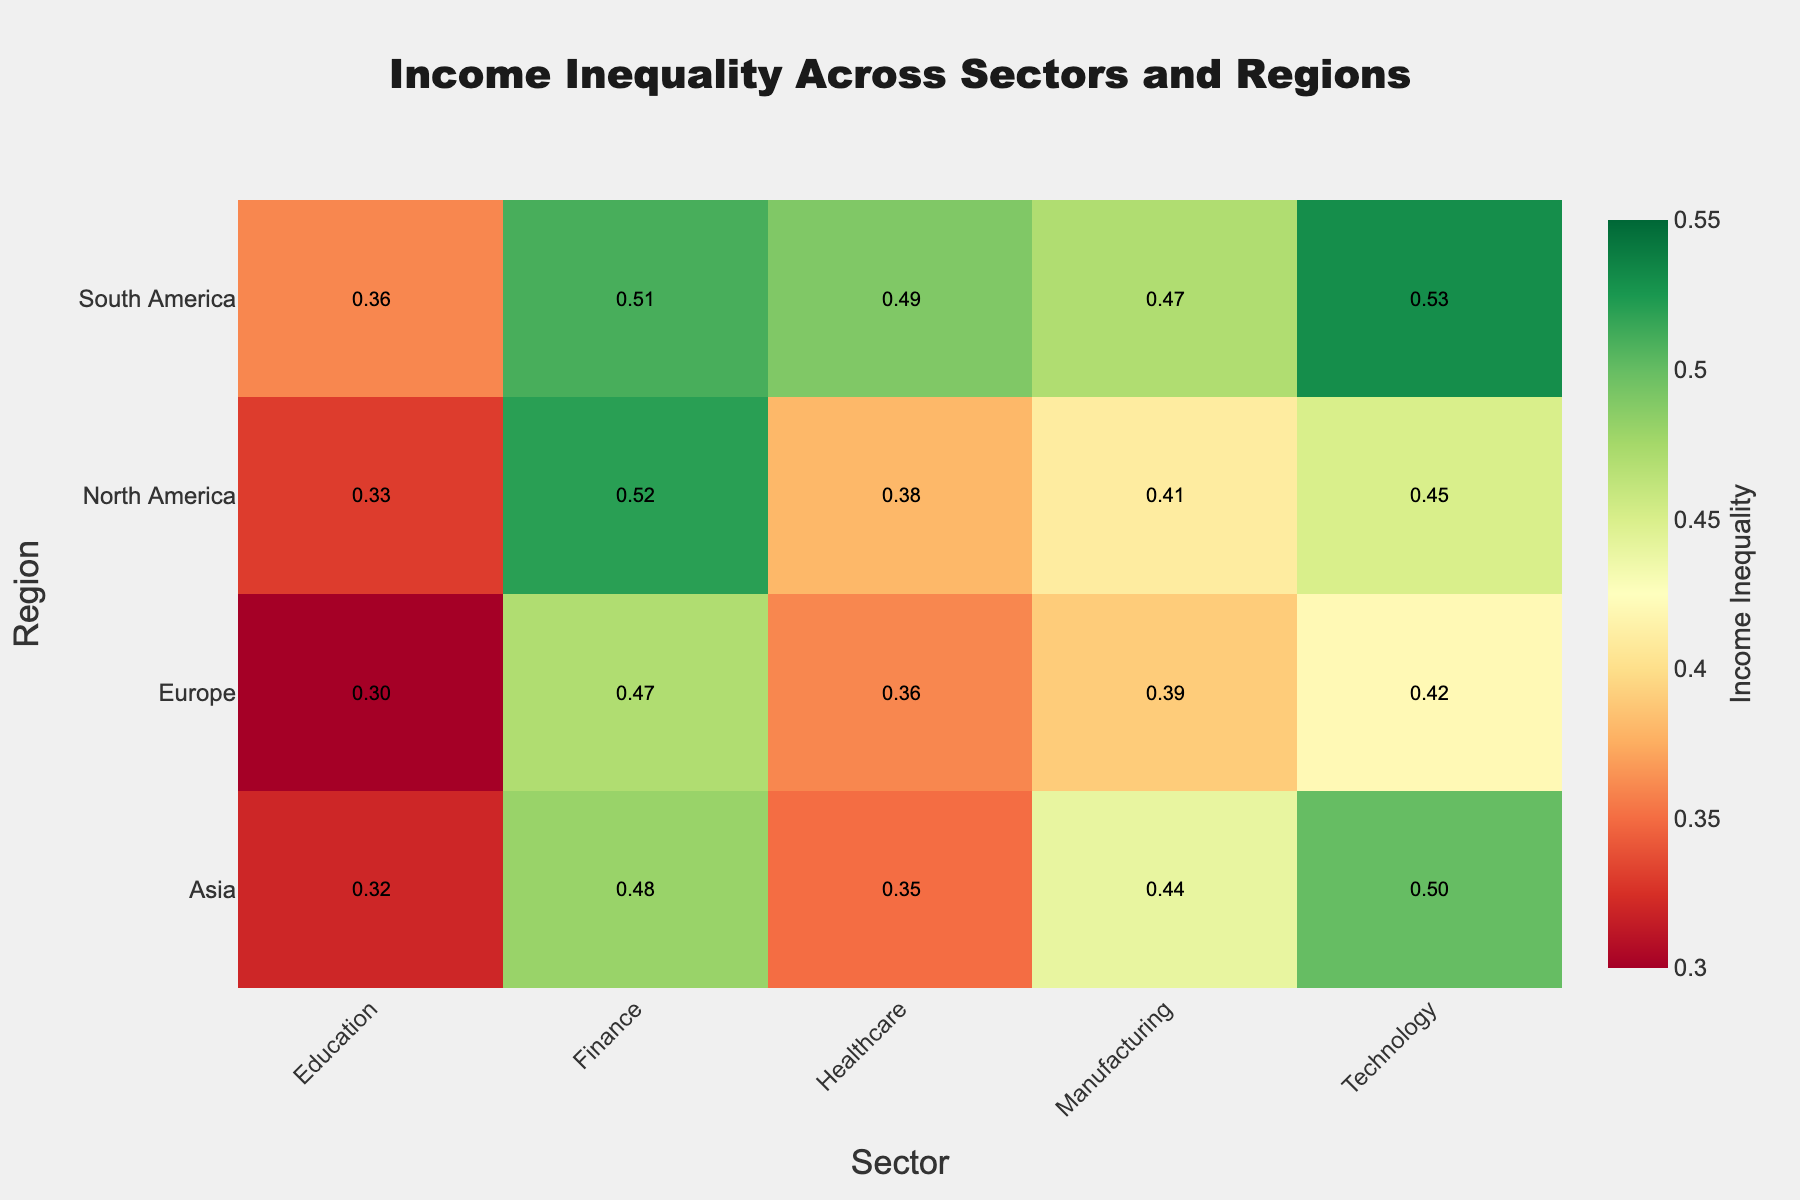What is the title of the heatmap? The title is usually located at the top of the figure. The title of this heatmap can be found there.
Answer: Income Inequality Across Sectors and Regions Which region and sector combination has the highest income inequality? By looking at the colors and annotations in the heatmap, identify the cell with the highest value. The color scale shows higher values in darker shades.
Answer: Technology in South America Which region has the lowest income inequality in the Healthcare sector? Locate the column for Healthcare and compare the annotated values across the rows representing different regions. The region with the smallest number is the answer.
Answer: Europe What is the average income inequality in the Technology sector across all regions? Locate the column for Technology and find the annotated values for each region (0.45, 0.42, 0.50, 0.53). Calculate the average: (0.45 + 0.42 + 0.50 + 0.53) / 4 = 1.90 / 4 = 0.475.
Answer: 0.475 Which sector in North America has the least income inequality? Locate the row for North America and then identify the cell with the lightest shade and smallest annotated value.
Answer: Education Compare the income inequality between the Finance sector in North America and Europe. Which is higher? Find the Finance column and then look at the rows for North America and Europe. Compare the annotated values (0.52 for North America and 0.47 for Europe).
Answer: North America In which region does the Manufacturing sector have the greatest income inequality? Locate the column for Manufacturing and compare the values. Identify the region with the highest value.
Answer: Asia Is the income inequality in the Education sector higher in South America or Asia? Locate the column for Education and compare the values for South America and Asia (0.36 for South America and 0.32 for Asia).
Answer: South America How does the income inequality in the Healthcare sector in Asia compare to that in South America? Locate the column for Healthcare and compare the annotated values for Asia (0.35) to that in South America (0.49).
Answer: Higher in South America What can you infer about the diversity of income inequality across regions for the Finance sector? Compare the annotated values for the Finance sector across all regions (0.52, 0.47, 0.48, 0.51). Observing the range and variance, we note that Finance sector income inequality is relatively high but shows slight variation across regions.
Answer: Slightly varied but high overall 